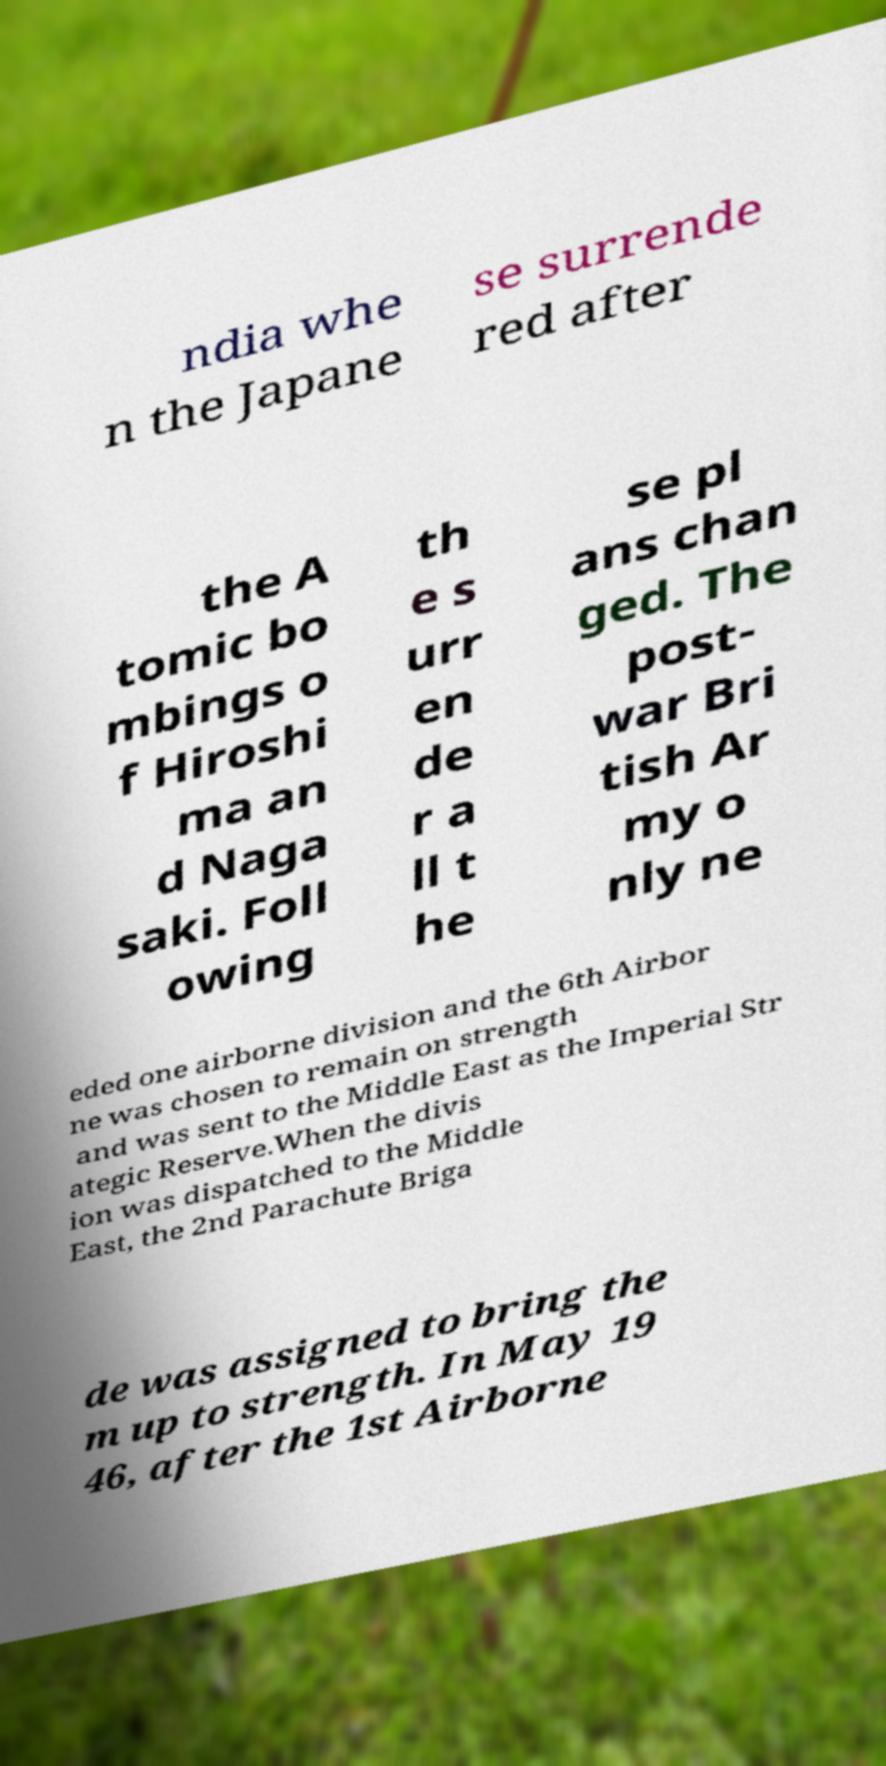Could you extract and type out the text from this image? ndia whe n the Japane se surrende red after the A tomic bo mbings o f Hiroshi ma an d Naga saki. Foll owing th e s urr en de r a ll t he se pl ans chan ged. The post- war Bri tish Ar my o nly ne eded one airborne division and the 6th Airbor ne was chosen to remain on strength and was sent to the Middle East as the Imperial Str ategic Reserve.When the divis ion was dispatched to the Middle East, the 2nd Parachute Briga de was assigned to bring the m up to strength. In May 19 46, after the 1st Airborne 